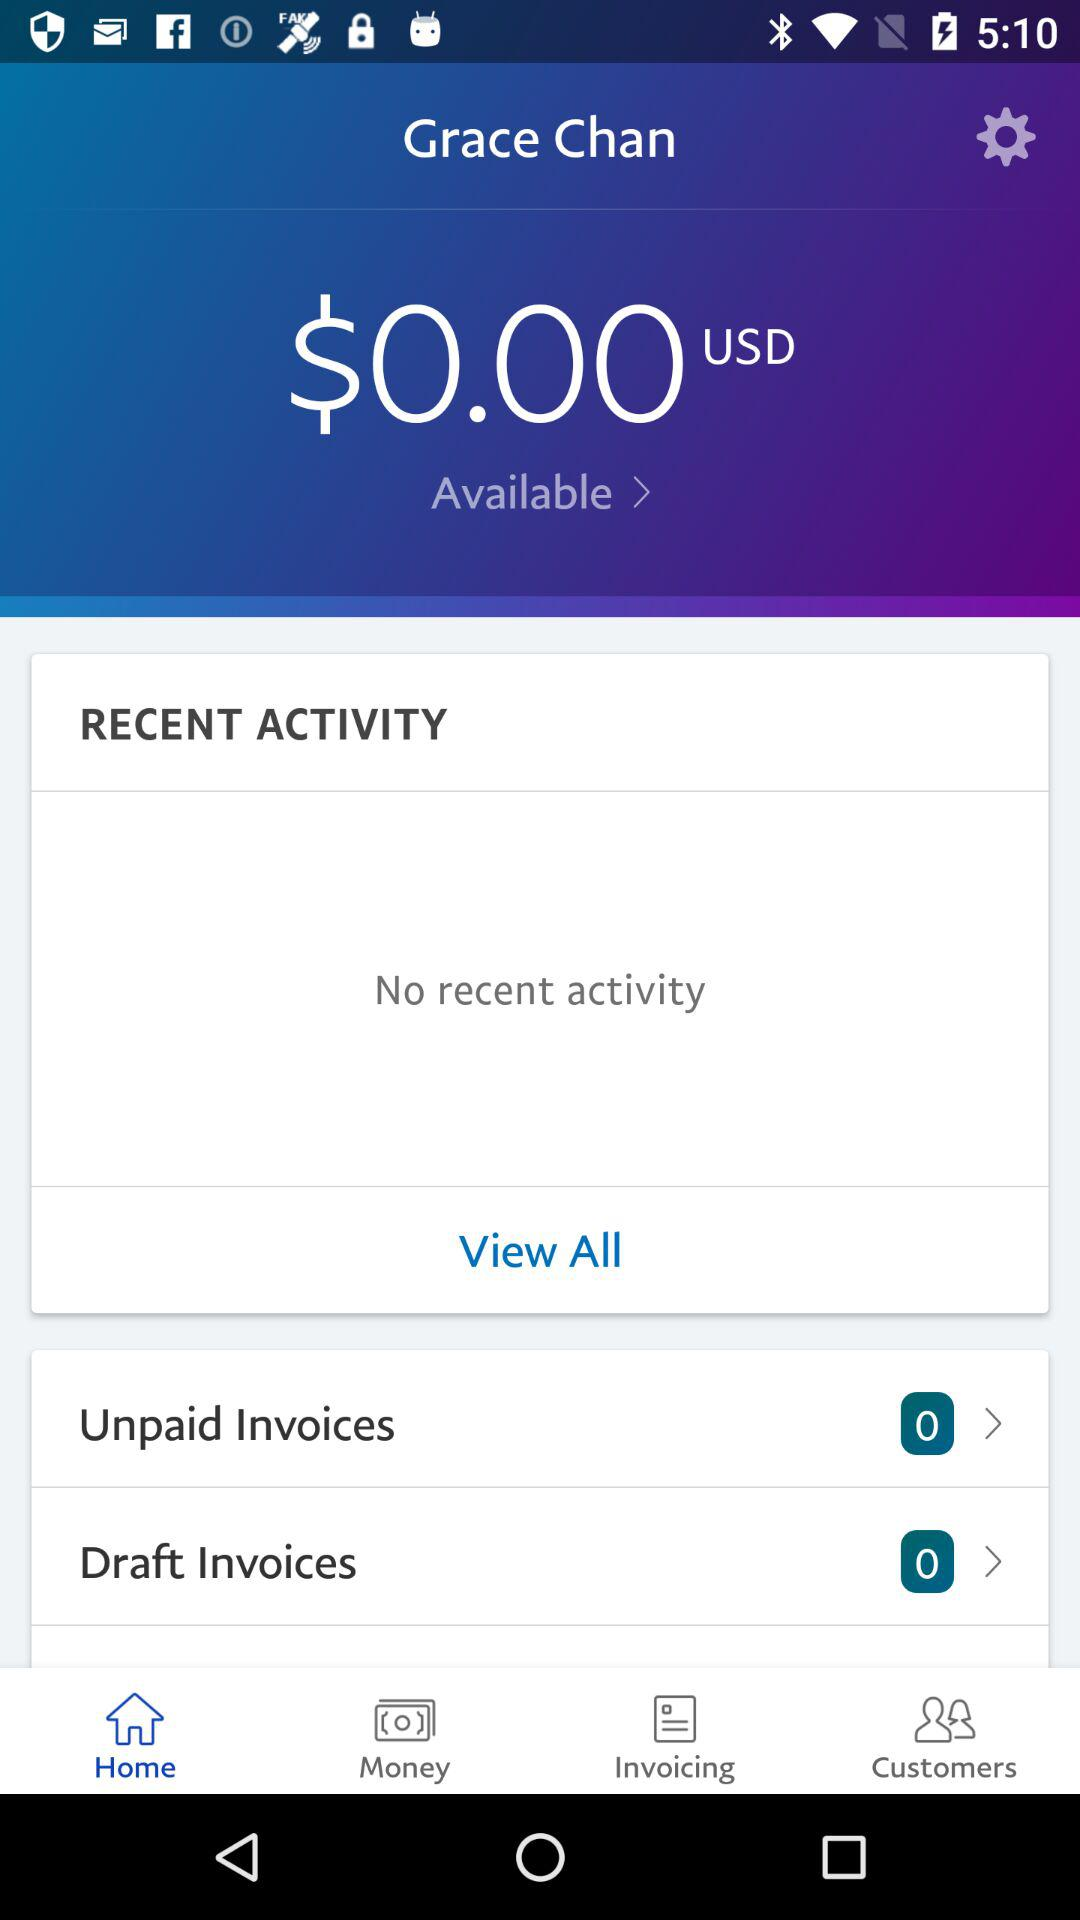How much money is available?
Answer the question using a single word or phrase. $0.00 